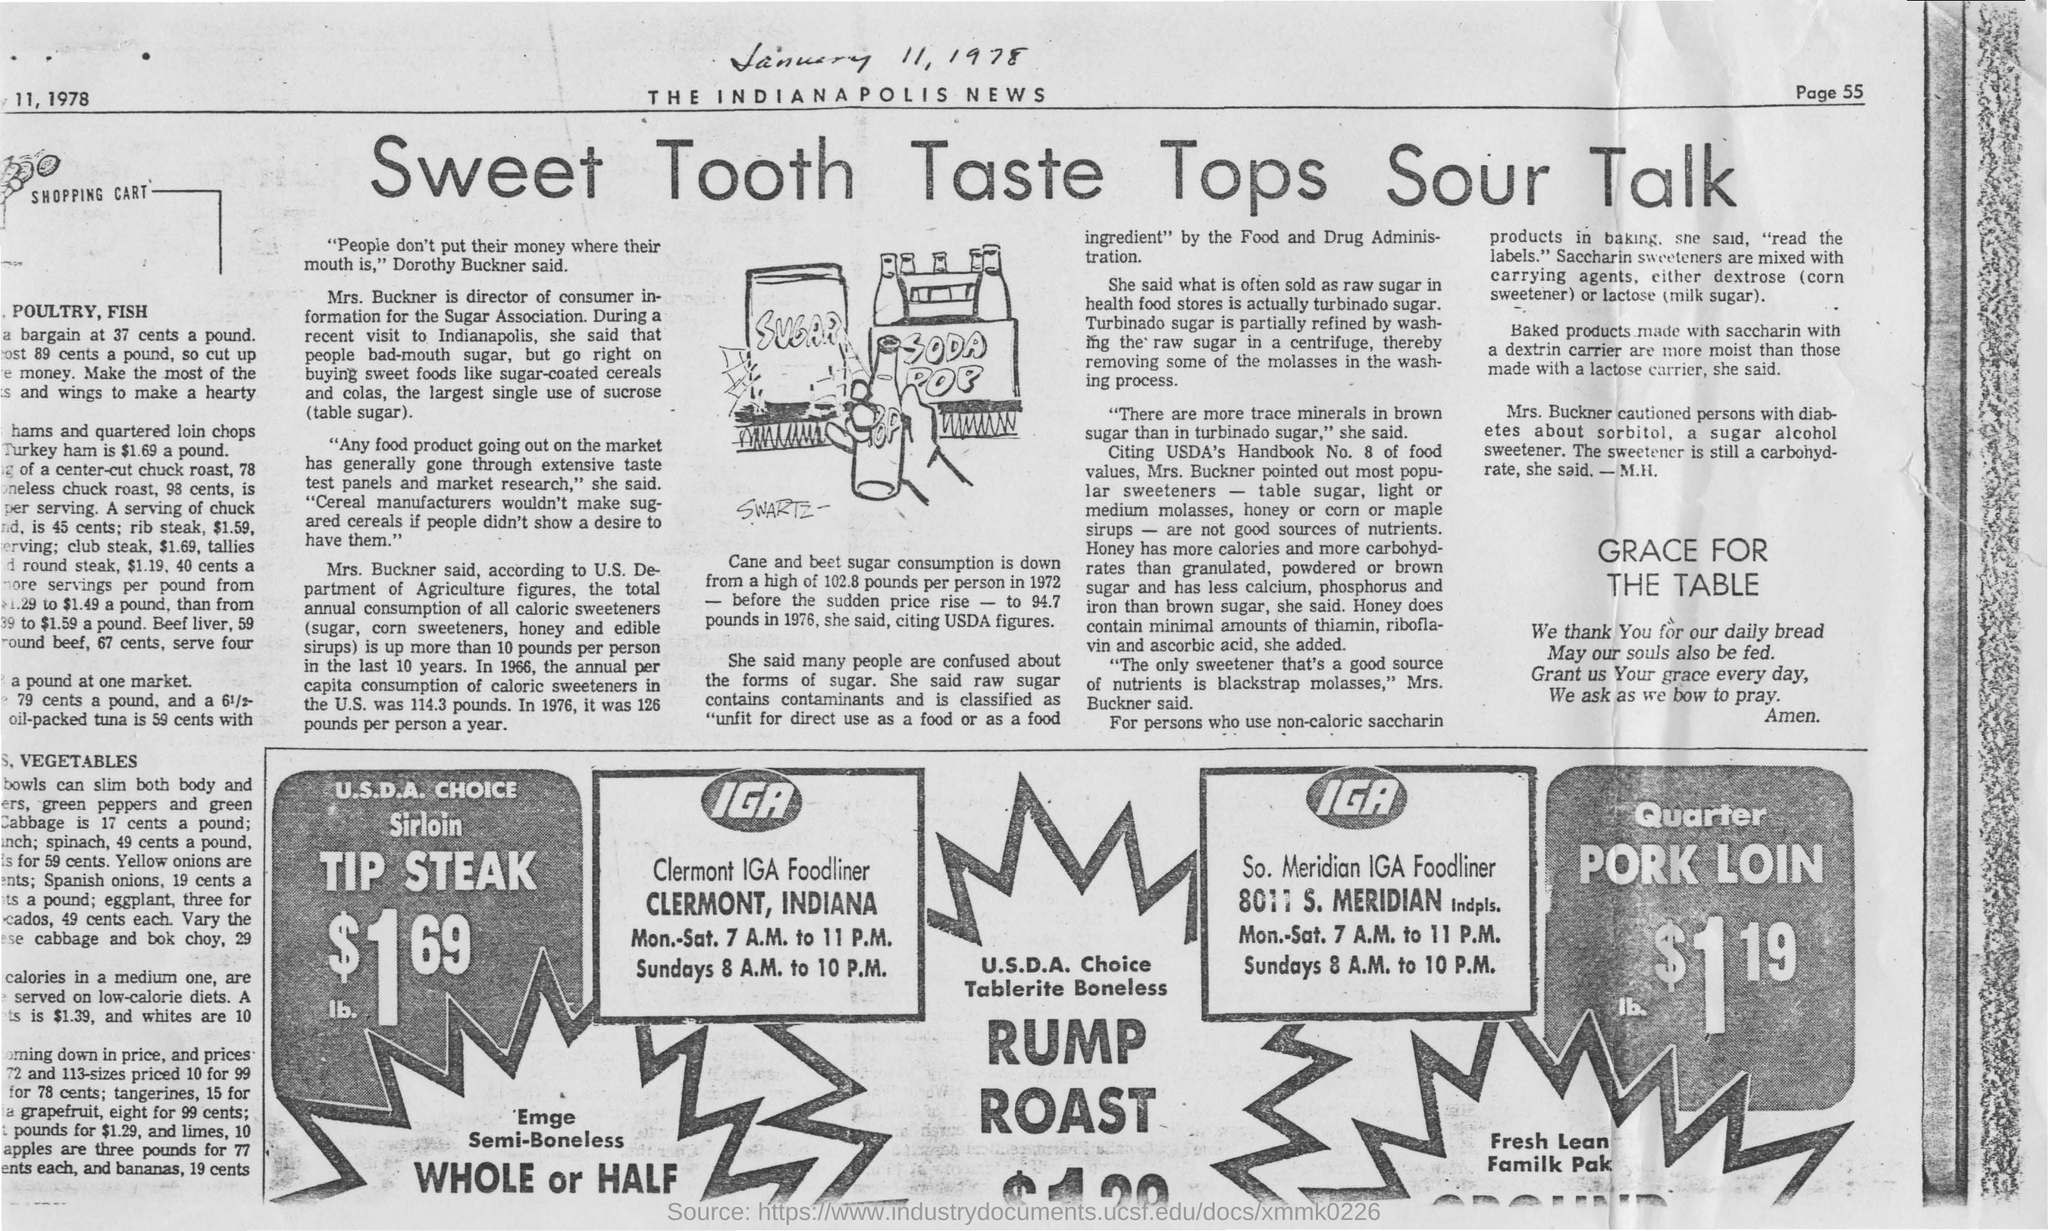Identify some key points in this picture. The cost of pork loin is $1.19. The document heading is 'sweet tooth taste tops sour talk'. The cost of TIP STEAK is $1.69. The operating hours for Clermont IGA foodliner on Sundays are from 8:00 A.M. to 10:00 P.M. 